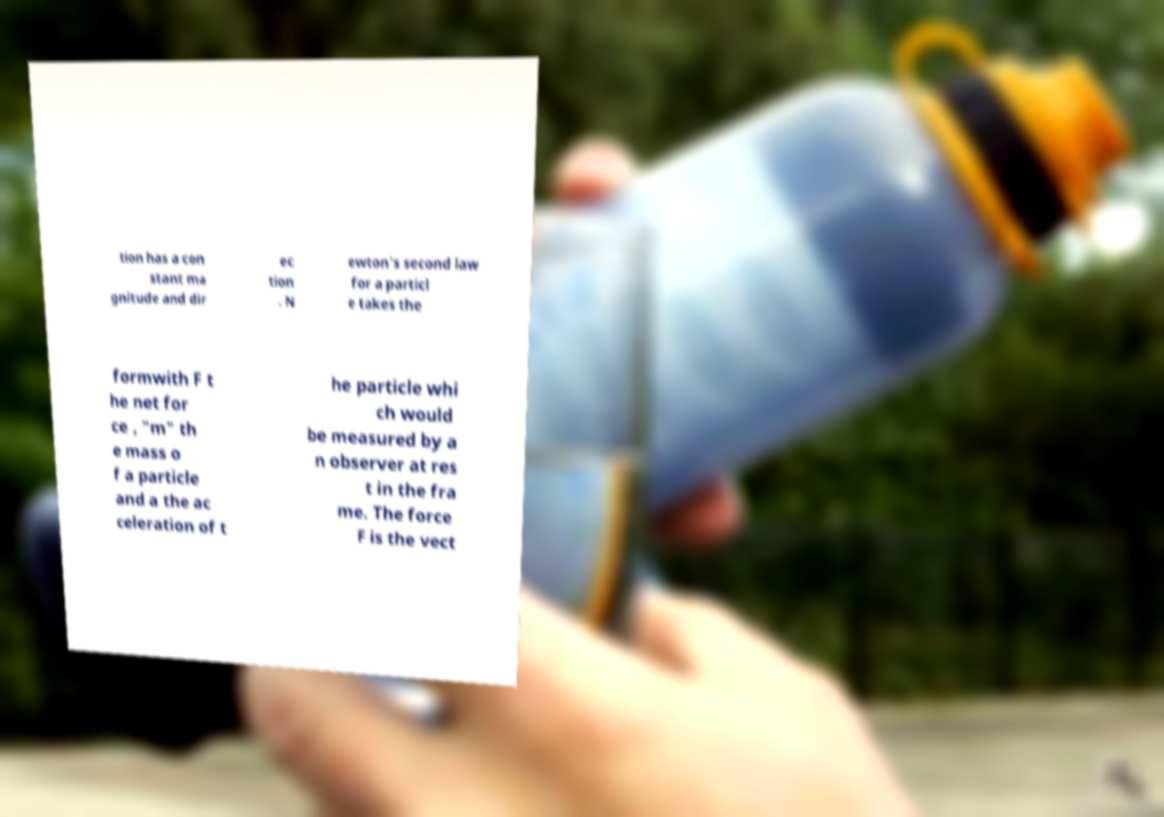For documentation purposes, I need the text within this image transcribed. Could you provide that? tion has a con stant ma gnitude and dir ec tion . N ewton's second law for a particl e takes the formwith F t he net for ce , "m" th e mass o f a particle and a the ac celeration of t he particle whi ch would be measured by a n observer at res t in the fra me. The force F is the vect 